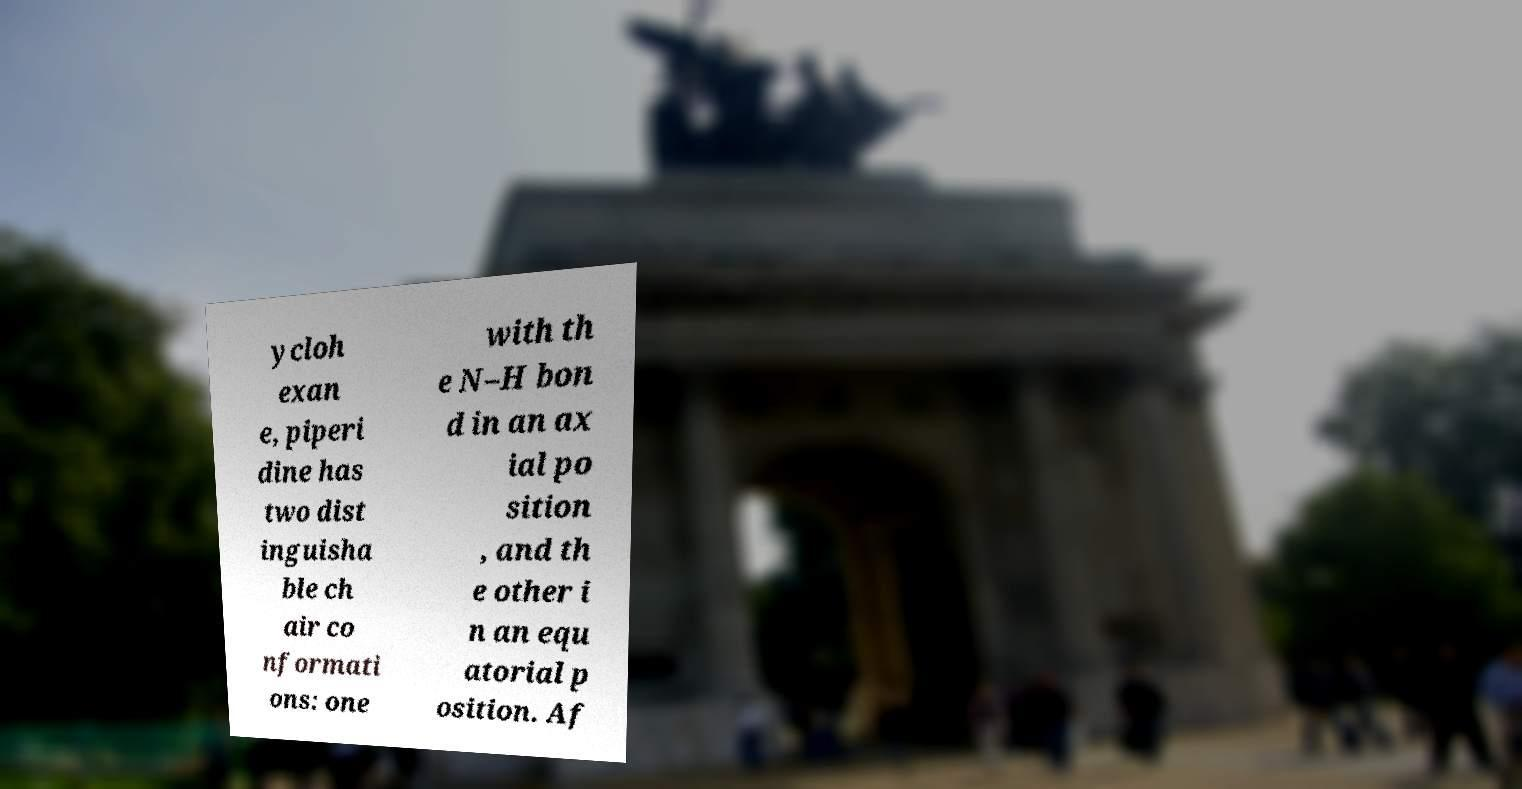Can you accurately transcribe the text from the provided image for me? ycloh exan e, piperi dine has two dist inguisha ble ch air co nformati ons: one with th e N–H bon d in an ax ial po sition , and th e other i n an equ atorial p osition. Af 